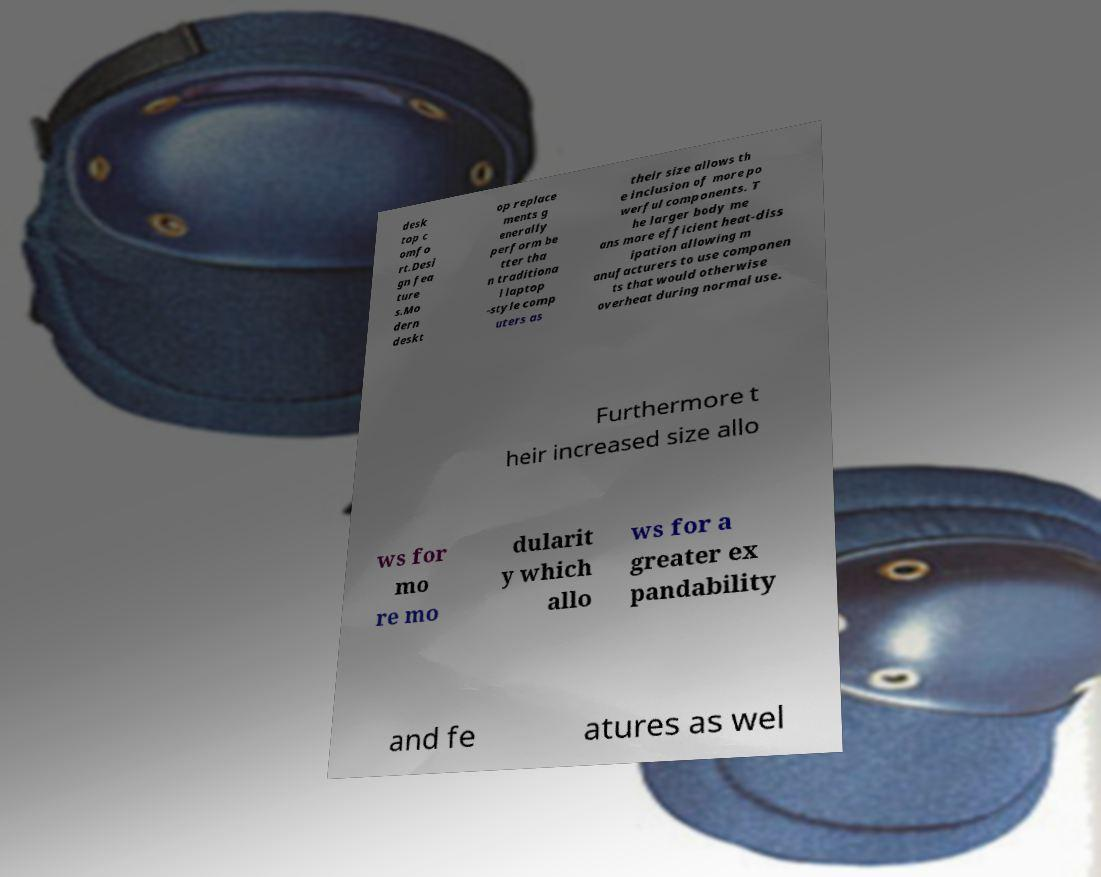Please identify and transcribe the text found in this image. desk top c omfo rt.Desi gn fea ture s.Mo dern deskt op replace ments g enerally perform be tter tha n traditiona l laptop -style comp uters as their size allows th e inclusion of more po werful components. T he larger body me ans more efficient heat-diss ipation allowing m anufacturers to use componen ts that would otherwise overheat during normal use. Furthermore t heir increased size allo ws for mo re mo dularit y which allo ws for a greater ex pandability and fe atures as wel 